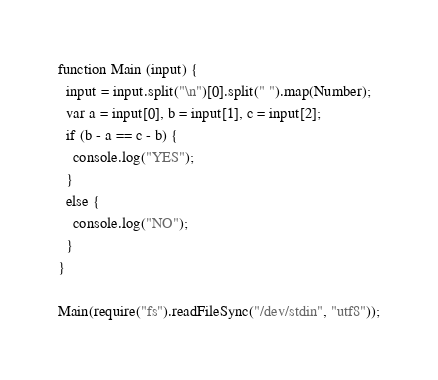<code> <loc_0><loc_0><loc_500><loc_500><_JavaScript_>function Main (input) {
  input = input.split("\n")[0].split(" ").map(Number);
  var a = input[0], b = input[1], c = input[2];
  if (b - a == c - b) {
    console.log("YES");
  }
  else {
    console.log("NO");
  }
}

Main(require("fs").readFileSync("/dev/stdin", "utf8"));</code> 